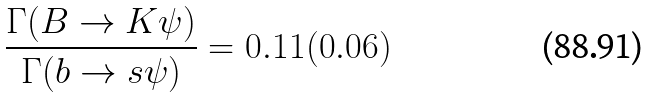Convert formula to latex. <formula><loc_0><loc_0><loc_500><loc_500>\frac { \Gamma ( B \rightarrow K \psi ) } { \Gamma ( b \rightarrow s \psi ) } = 0 . 1 1 ( 0 . 0 6 )</formula> 